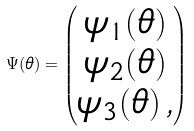<formula> <loc_0><loc_0><loc_500><loc_500>\Psi ( \theta ) = \begin{pmatrix} \psi _ { 1 } ( \theta ) \\ \psi _ { 2 } ( \theta ) \\ \psi _ { 3 } ( \theta ) \, , \end{pmatrix}</formula> 